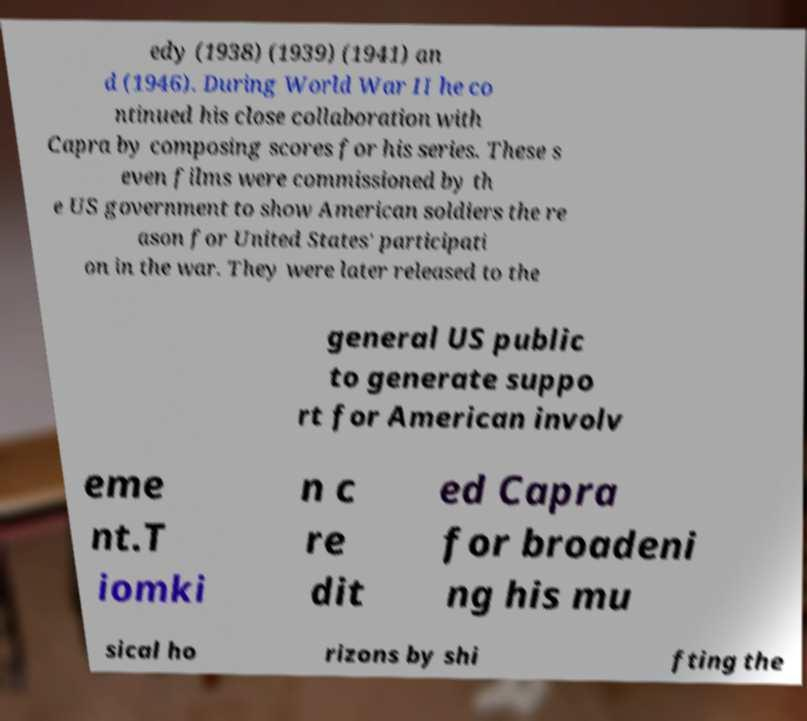What messages or text are displayed in this image? I need them in a readable, typed format. edy (1938) (1939) (1941) an d (1946). During World War II he co ntinued his close collaboration with Capra by composing scores for his series. These s even films were commissioned by th e US government to show American soldiers the re ason for United States' participati on in the war. They were later released to the general US public to generate suppo rt for American involv eme nt.T iomki n c re dit ed Capra for broadeni ng his mu sical ho rizons by shi fting the 